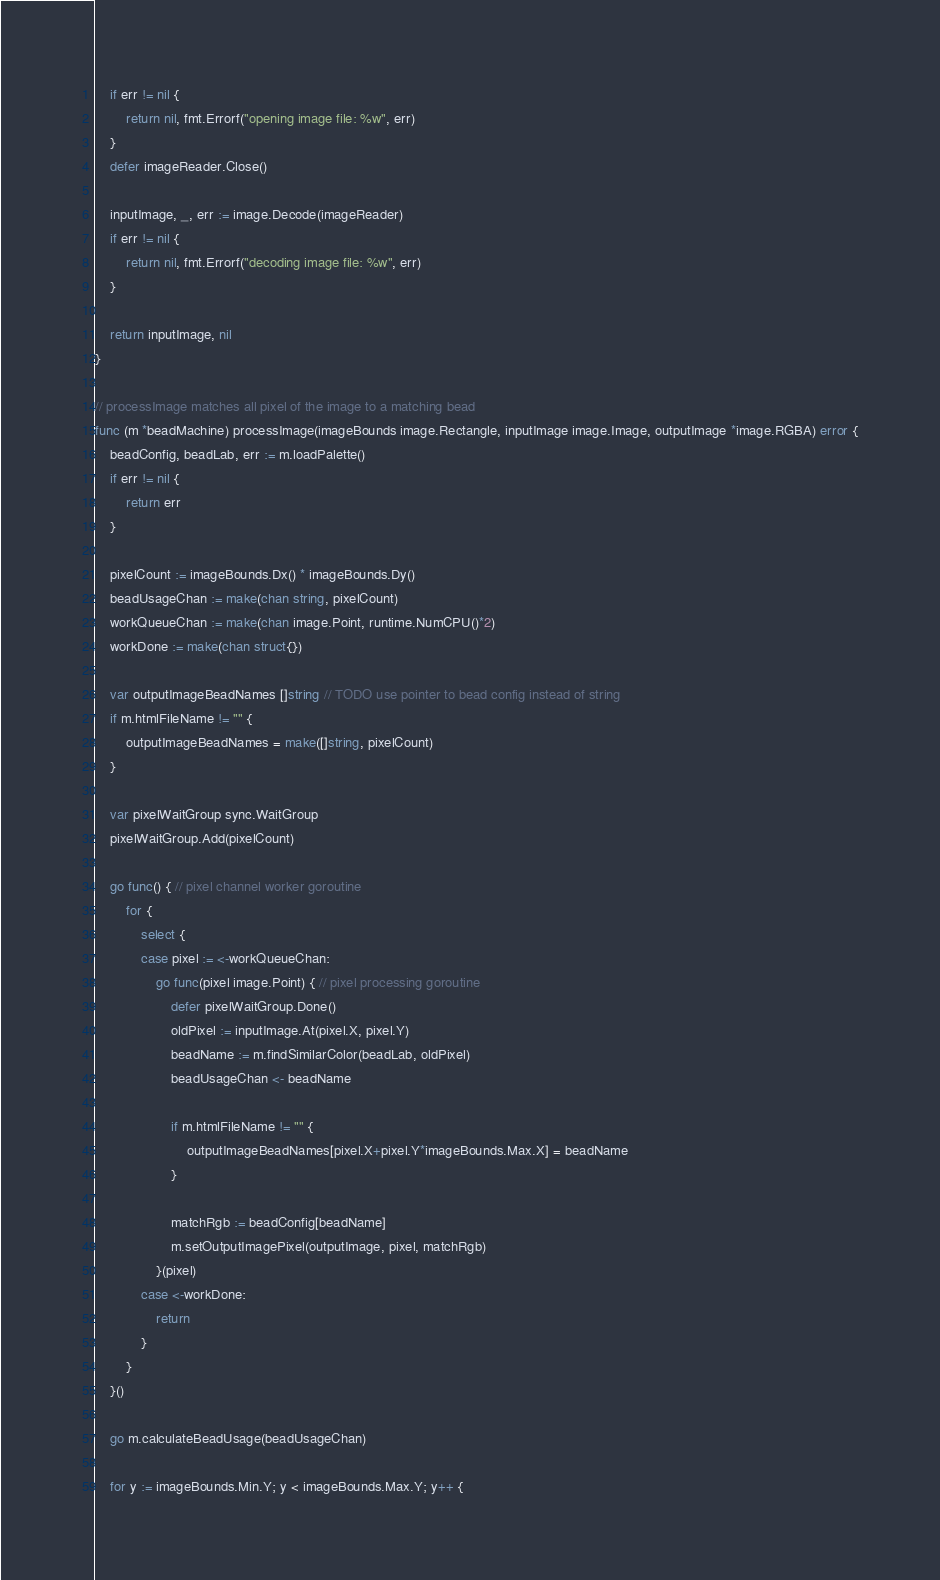Convert code to text. <code><loc_0><loc_0><loc_500><loc_500><_Go_>	if err != nil {
		return nil, fmt.Errorf("opening image file: %w", err)
	}
	defer imageReader.Close()

	inputImage, _, err := image.Decode(imageReader)
	if err != nil {
		return nil, fmt.Errorf("decoding image file: %w", err)
	}

	return inputImage, nil
}

// processImage matches all pixel of the image to a matching bead
func (m *beadMachine) processImage(imageBounds image.Rectangle, inputImage image.Image, outputImage *image.RGBA) error {
	beadConfig, beadLab, err := m.loadPalette()
	if err != nil {
		return err
	}

	pixelCount := imageBounds.Dx() * imageBounds.Dy()
	beadUsageChan := make(chan string, pixelCount)
	workQueueChan := make(chan image.Point, runtime.NumCPU()*2)
	workDone := make(chan struct{})

	var outputImageBeadNames []string // TODO use pointer to bead config instead of string
	if m.htmlFileName != "" {
		outputImageBeadNames = make([]string, pixelCount)
	}

	var pixelWaitGroup sync.WaitGroup
	pixelWaitGroup.Add(pixelCount)

	go func() { // pixel channel worker goroutine
		for {
			select {
			case pixel := <-workQueueChan:
				go func(pixel image.Point) { // pixel processing goroutine
					defer pixelWaitGroup.Done()
					oldPixel := inputImage.At(pixel.X, pixel.Y)
					beadName := m.findSimilarColor(beadLab, oldPixel)
					beadUsageChan <- beadName

					if m.htmlFileName != "" {
						outputImageBeadNames[pixel.X+pixel.Y*imageBounds.Max.X] = beadName
					}

					matchRgb := beadConfig[beadName]
					m.setOutputImagePixel(outputImage, pixel, matchRgb)
				}(pixel)
			case <-workDone:
				return
			}
		}
	}()

	go m.calculateBeadUsage(beadUsageChan)

	for y := imageBounds.Min.Y; y < imageBounds.Max.Y; y++ {</code> 